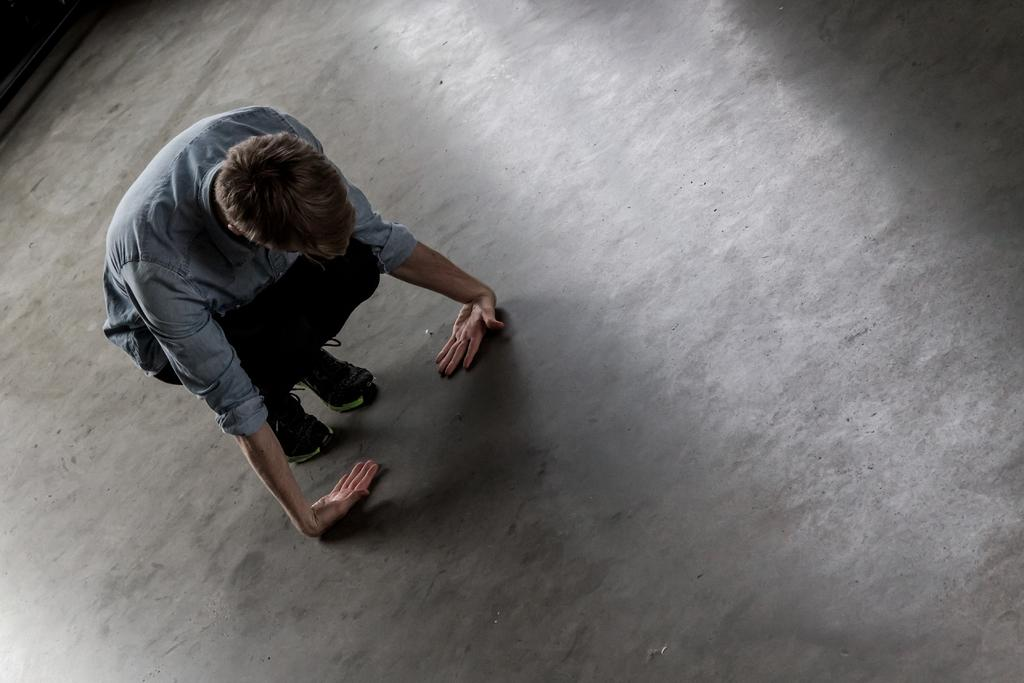Who or what is the main subject in the image? There is a person in the image. What position is the person in? The person is sitting in a squatting position. How are the person's hands positioned in relation to their body? The person has placed their hands on the floor. What type of cord is the person using to communicate in the image? There is no cord present in the image, and the person is not communicating through any visible means. 